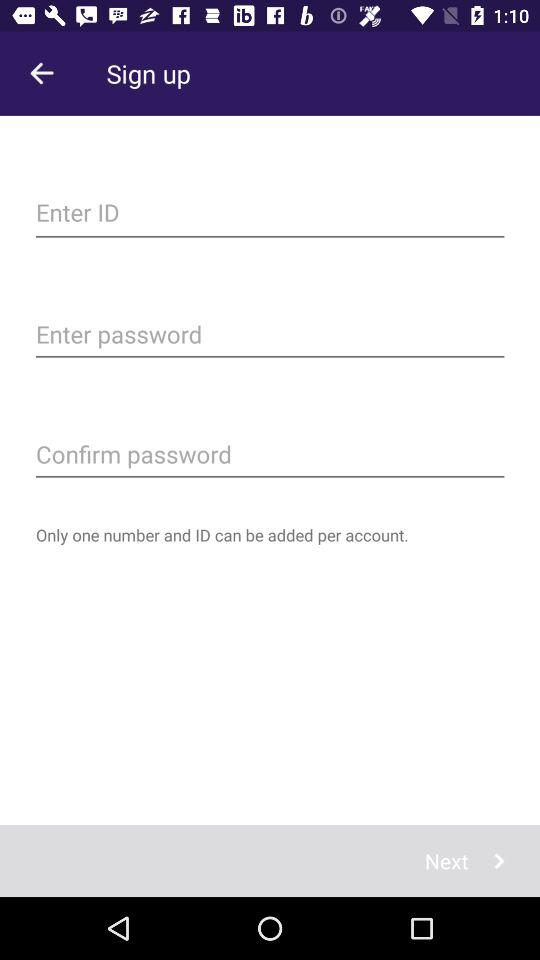How many fields are there for entering information?
Answer the question using a single word or phrase. 3 